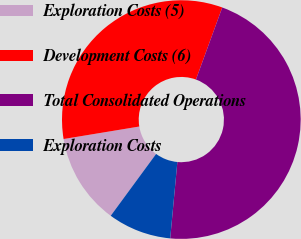Convert chart to OTSL. <chart><loc_0><loc_0><loc_500><loc_500><pie_chart><fcel>Exploration Costs (5)<fcel>Development Costs (6)<fcel>Total Consolidated Operations<fcel>Exploration Costs<nl><fcel>12.32%<fcel>33.18%<fcel>45.92%<fcel>8.59%<nl></chart> 